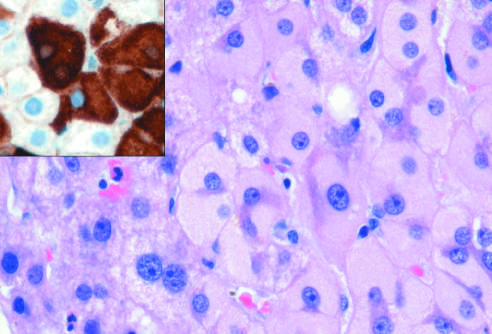what is caused by accumulation of hepatitis b surface antigen?
Answer the question using a single word or phrase. Ground-glass hepatocytes in chronic hepatitis b 